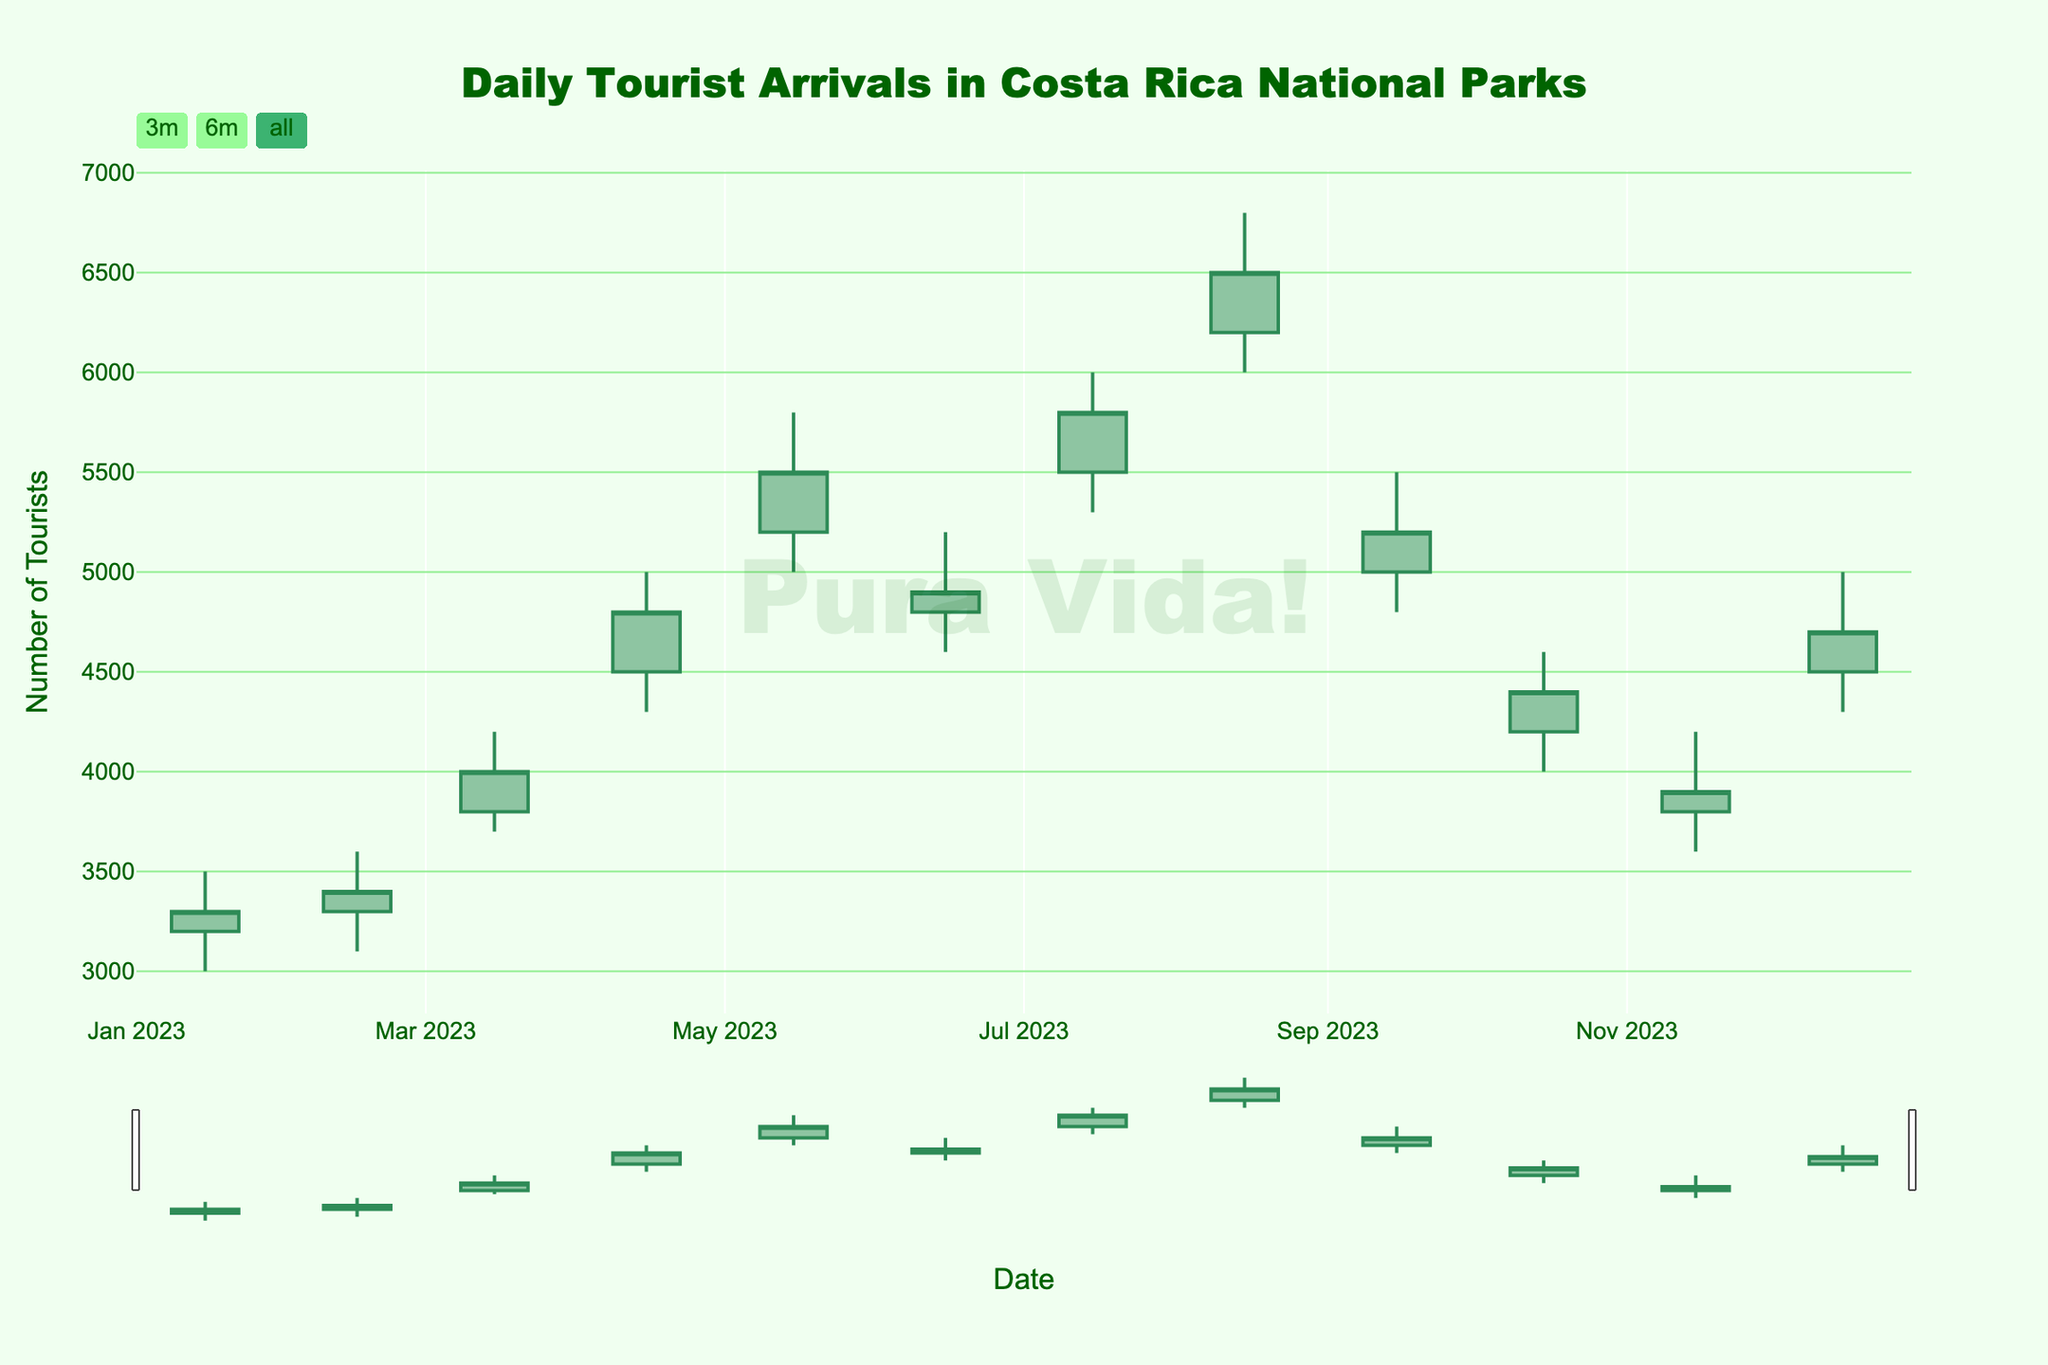What is the title of the chart? The title is prominently displayed at the top center of the chart. It reads, "Daily Tourist Arrivals in Costa Rica National Parks".
Answer: Daily Tourist Arrivals in Costa Rica National Parks What is the time range covered in the chart? The x-axis displays dates ranging from January 15, 2023, to December 15, 2023, indicating the time range covered in the chart.
Answer: January 15, 2023, to December 15, 2023 What month had the highest number of tourist arrivals? By examining the 'High' values of each month, we can see that August had the highest number of tourist arrivals with a peak value of 6800.
Answer: August Which month showed the largest fluctuation in tourist arrivals? Fluctuation can be observed by the difference between the 'High' and 'Low' values for each month. April's fluctuation is the largest, calculated as 5000 - 4300 = 700.
Answer: April How many months had a closing value higher than the opening value? By visually inspecting the color-coded candlesticks, green (increasing) indicates months where the closing value was higher than the opening value. There are 8 such months: February, March, April, May, July, August, October, and December.
Answer: 8 What was the closing value for May? The closing value for May can be found at the end of the candlestick for May. Checking the data, it is 5500.
Answer: 5500 Compare the tourist arrivals in January and February. Which month had higher overall tourist traffic? For overall tourist traffic, we consider 'High' values. January had a high of 3500, and February had a high of 3600. Thus, February had higher tourist traffic.
Answer: February What color is used to represent increasing tourist arrivals on the candlestick chart? Increasing tourist arrivals are represented by the color sea green, as seen on the chart and explained in the details.
Answer: Sea green Between which two consecutive months did we see the sharpest decline in the closing values of tourist arrivals? A sharp decline is indicated by a significant drop in the 'Close' values from one month to the next. Comparing the closing values, the sharpest decline occurred from August (6500) to September (5200), a decrease of 1300.
Answer: August to September 